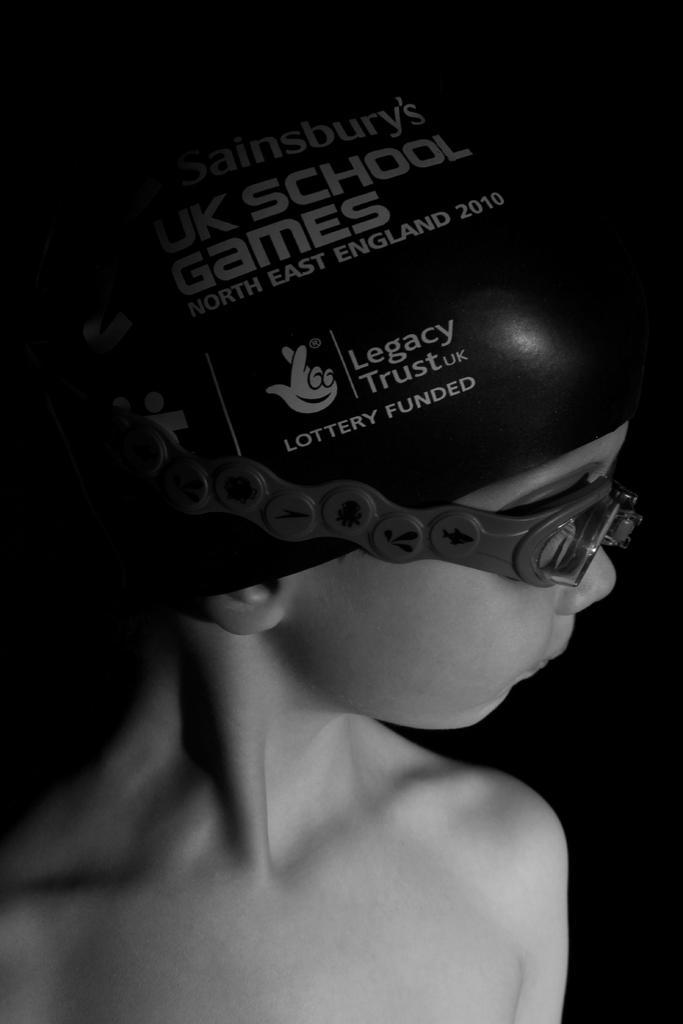How would you summarize this image in a sentence or two? It is a black and white image of a boy wearing the glasses and also the cap with text. 